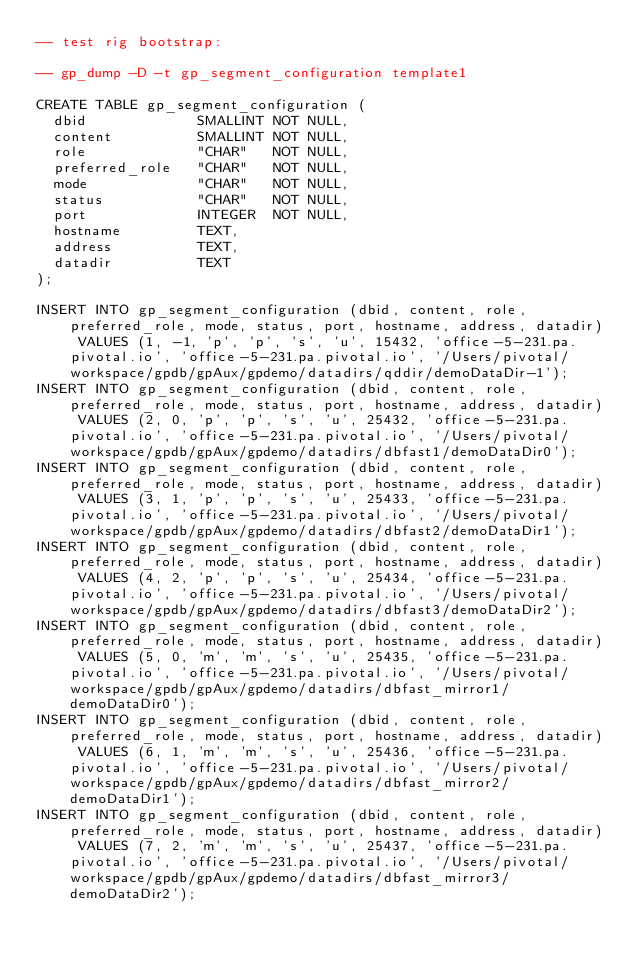Convert code to text. <code><loc_0><loc_0><loc_500><loc_500><_SQL_>-- test rig bootstrap:

-- gp_dump -D -t gp_segment_configuration template1

CREATE TABLE gp_segment_configuration (
  dbid             SMALLINT NOT NULL,
  content          SMALLINT NOT NULL,
  role             "CHAR"   NOT NULL,
  preferred_role   "CHAR"   NOT NULL,
  mode             "CHAR"   NOT NULL,
  status           "CHAR"   NOT NULL,
  port             INTEGER  NOT NULL,
  hostname         TEXT,
  address          TEXT,
  datadir          TEXT
);

INSERT INTO gp_segment_configuration (dbid, content, role, preferred_role, mode, status, port, hostname, address, datadir) VALUES (1, -1, 'p', 'p', 's', 'u', 15432, 'office-5-231.pa.pivotal.io', 'office-5-231.pa.pivotal.io', '/Users/pivotal/workspace/gpdb/gpAux/gpdemo/datadirs/qddir/demoDataDir-1');
INSERT INTO gp_segment_configuration (dbid, content, role, preferred_role, mode, status, port, hostname, address, datadir) VALUES (2, 0, 'p', 'p', 's', 'u', 25432, 'office-5-231.pa.pivotal.io', 'office-5-231.pa.pivotal.io', '/Users/pivotal/workspace/gpdb/gpAux/gpdemo/datadirs/dbfast1/demoDataDir0');
INSERT INTO gp_segment_configuration (dbid, content, role, preferred_role, mode, status, port, hostname, address, datadir) VALUES (3, 1, 'p', 'p', 's', 'u', 25433, 'office-5-231.pa.pivotal.io', 'office-5-231.pa.pivotal.io', '/Users/pivotal/workspace/gpdb/gpAux/gpdemo/datadirs/dbfast2/demoDataDir1');
INSERT INTO gp_segment_configuration (dbid, content, role, preferred_role, mode, status, port, hostname, address, datadir) VALUES (4, 2, 'p', 'p', 's', 'u', 25434, 'office-5-231.pa.pivotal.io', 'office-5-231.pa.pivotal.io', '/Users/pivotal/workspace/gpdb/gpAux/gpdemo/datadirs/dbfast3/demoDataDir2');
INSERT INTO gp_segment_configuration (dbid, content, role, preferred_role, mode, status, port, hostname, address, datadir) VALUES (5, 0, 'm', 'm', 's', 'u', 25435, 'office-5-231.pa.pivotal.io', 'office-5-231.pa.pivotal.io', '/Users/pivotal/workspace/gpdb/gpAux/gpdemo/datadirs/dbfast_mirror1/demoDataDir0');
INSERT INTO gp_segment_configuration (dbid, content, role, preferred_role, mode, status, port, hostname, address, datadir) VALUES (6, 1, 'm', 'm', 's', 'u', 25436, 'office-5-231.pa.pivotal.io', 'office-5-231.pa.pivotal.io', '/Users/pivotal/workspace/gpdb/gpAux/gpdemo/datadirs/dbfast_mirror2/demoDataDir1');
INSERT INTO gp_segment_configuration (dbid, content, role, preferred_role, mode, status, port, hostname, address, datadir) VALUES (7, 2, 'm', 'm', 's', 'u', 25437, 'office-5-231.pa.pivotal.io', 'office-5-231.pa.pivotal.io', '/Users/pivotal/workspace/gpdb/gpAux/gpdemo/datadirs/dbfast_mirror3/demoDataDir2');

</code> 